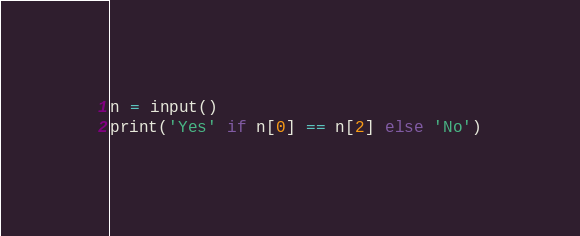Convert code to text. <code><loc_0><loc_0><loc_500><loc_500><_Python_>n = input()
print('Yes' if n[0] == n[2] else 'No')</code> 